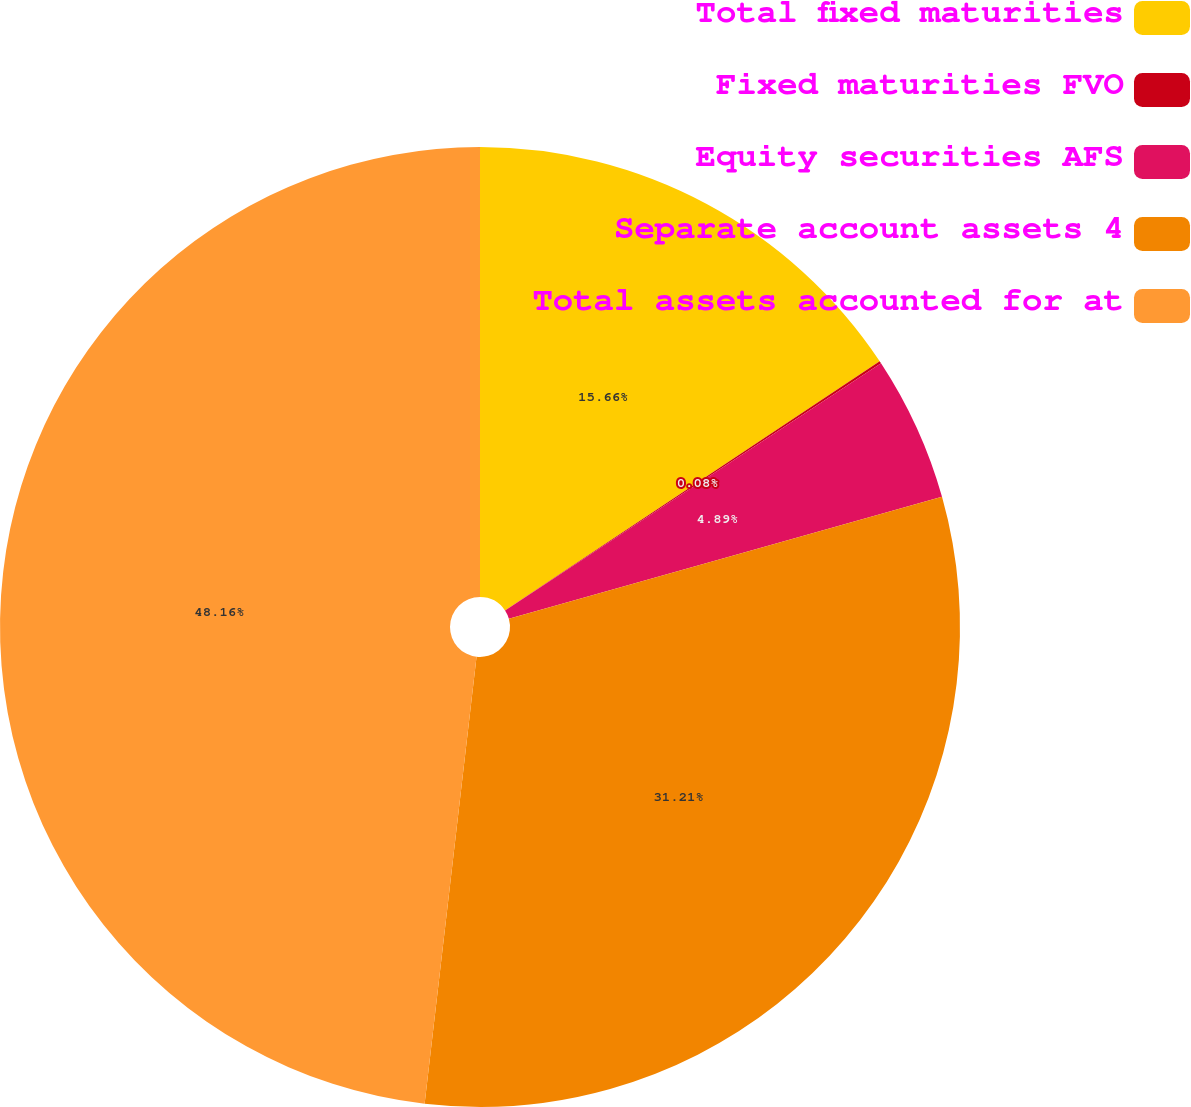Convert chart to OTSL. <chart><loc_0><loc_0><loc_500><loc_500><pie_chart><fcel>Total fixed maturities<fcel>Fixed maturities FVO<fcel>Equity securities AFS<fcel>Separate account assets 4<fcel>Total assets accounted for at<nl><fcel>15.66%<fcel>0.08%<fcel>4.89%<fcel>31.21%<fcel>48.16%<nl></chart> 